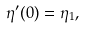<formula> <loc_0><loc_0><loc_500><loc_500>\eta ^ { \prime } ( 0 ) = \eta _ { 1 } ,</formula> 